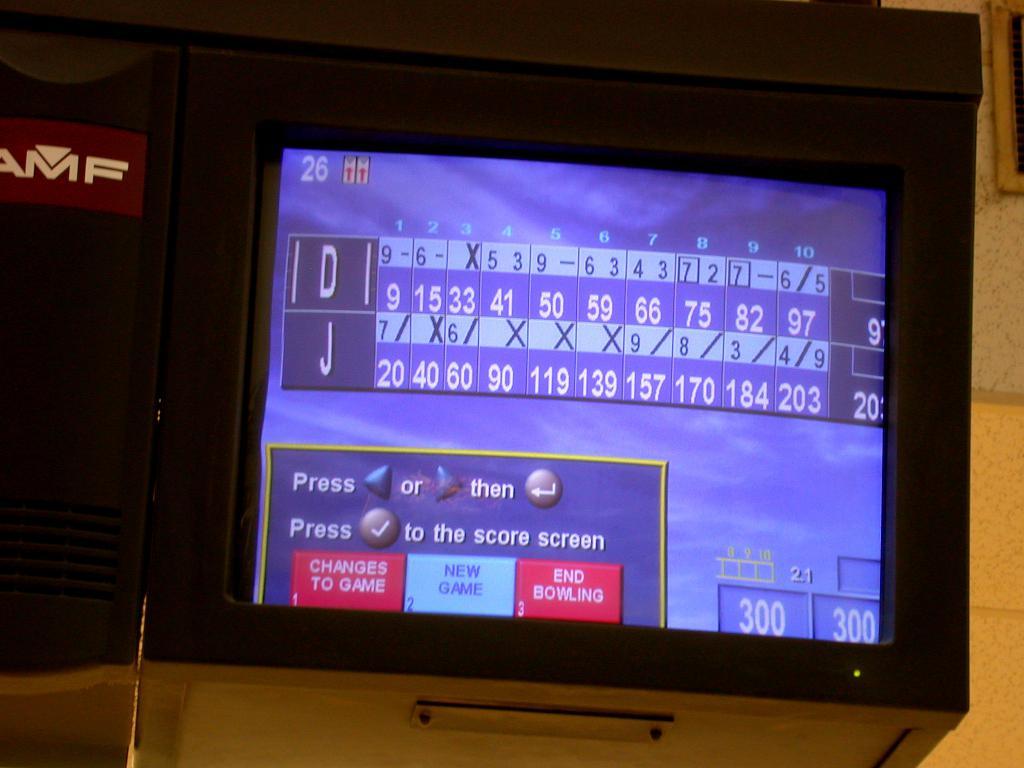What is the score for j?
Provide a short and direct response. 203. What is the score for d?
Provide a short and direct response. 97. 